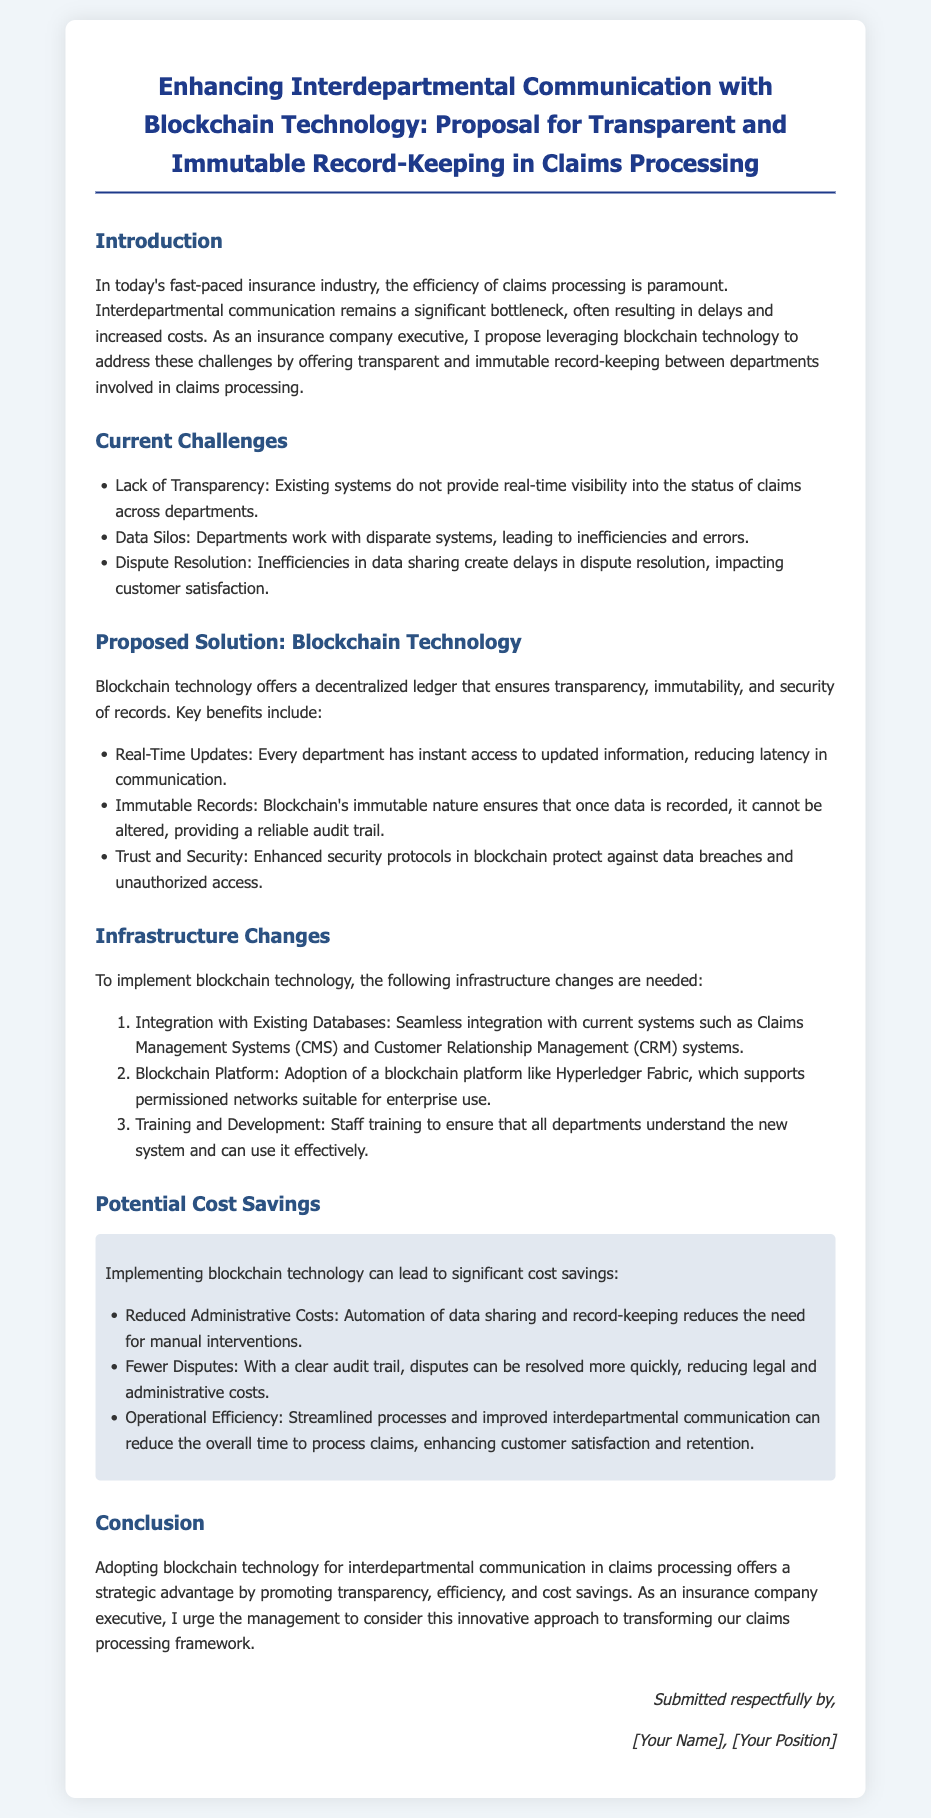what is the title of the document? The title is the heading found at the top of the document, summarizing its primary focus.
Answer: Enhancing Interdepartmental Communication with Blockchain Technology: Proposal for Transparent and Immutable Record-Keeping in Claims Processing what are the current challenges mentioned in the document? The challenges are listed as bullet points in the relevant section, highlighting key issues faced in claims processing.
Answer: Lack of Transparency, Data Silos, Dispute Resolution what blockchain platform is suggested for implementation? The proposed platform is specified in the infrastructure changes section of the document.
Answer: Hyperledger Fabric how many infrastructure changes are described in the document? The number of changes is indicated by the number of items in the list provided in the infrastructure changes section.
Answer: Three what benefit does blockchain provide concerning data records? The document emphasizes a specific quality of blockchain records that enhances reliability and trust.
Answer: Immutable Records what are the potential cost savings mentioned? The potential savings are outlined as key benefits related to implementing blockchain technology in claims processing.
Answer: Reduced Administrative Costs, Fewer Disputes, Operational Efficiency what is the main goal of the proposed solution in the document? The main goal is articulated in the introduction section, focusing on the overarching benefit intended by the proposal.
Answer: Efficiency of claims processing who submitted the petition? The document indicates the person responsible for submitting the petition in the sign-off section.
Answer: [Your Name], [Your Position] 